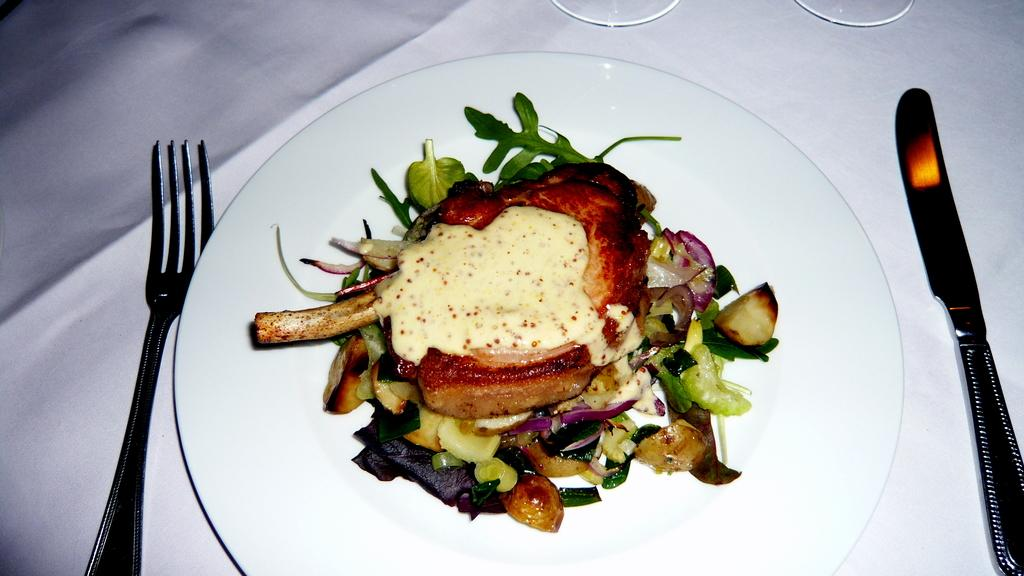What type of dishware is used to hold the food items in the image? There is a white color plate holding the food items in the image. What utensils are present near the plate? There is a fork on the left side of the plate and a knife on the right side of the plate. What type of toothbrush is being used to clean the food items in the image? There is no toothbrush present in the image, and the food items are not being cleaned. 